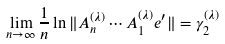<formula> <loc_0><loc_0><loc_500><loc_500>\lim _ { n \to \infty } \frac { 1 } { n } \ln \| A _ { n } ^ { ( \lambda ) } \cdots A _ { 1 } ^ { ( \lambda ) } e ^ { \prime } \| = \gamma _ { 2 } ^ { ( \lambda ) }</formula> 